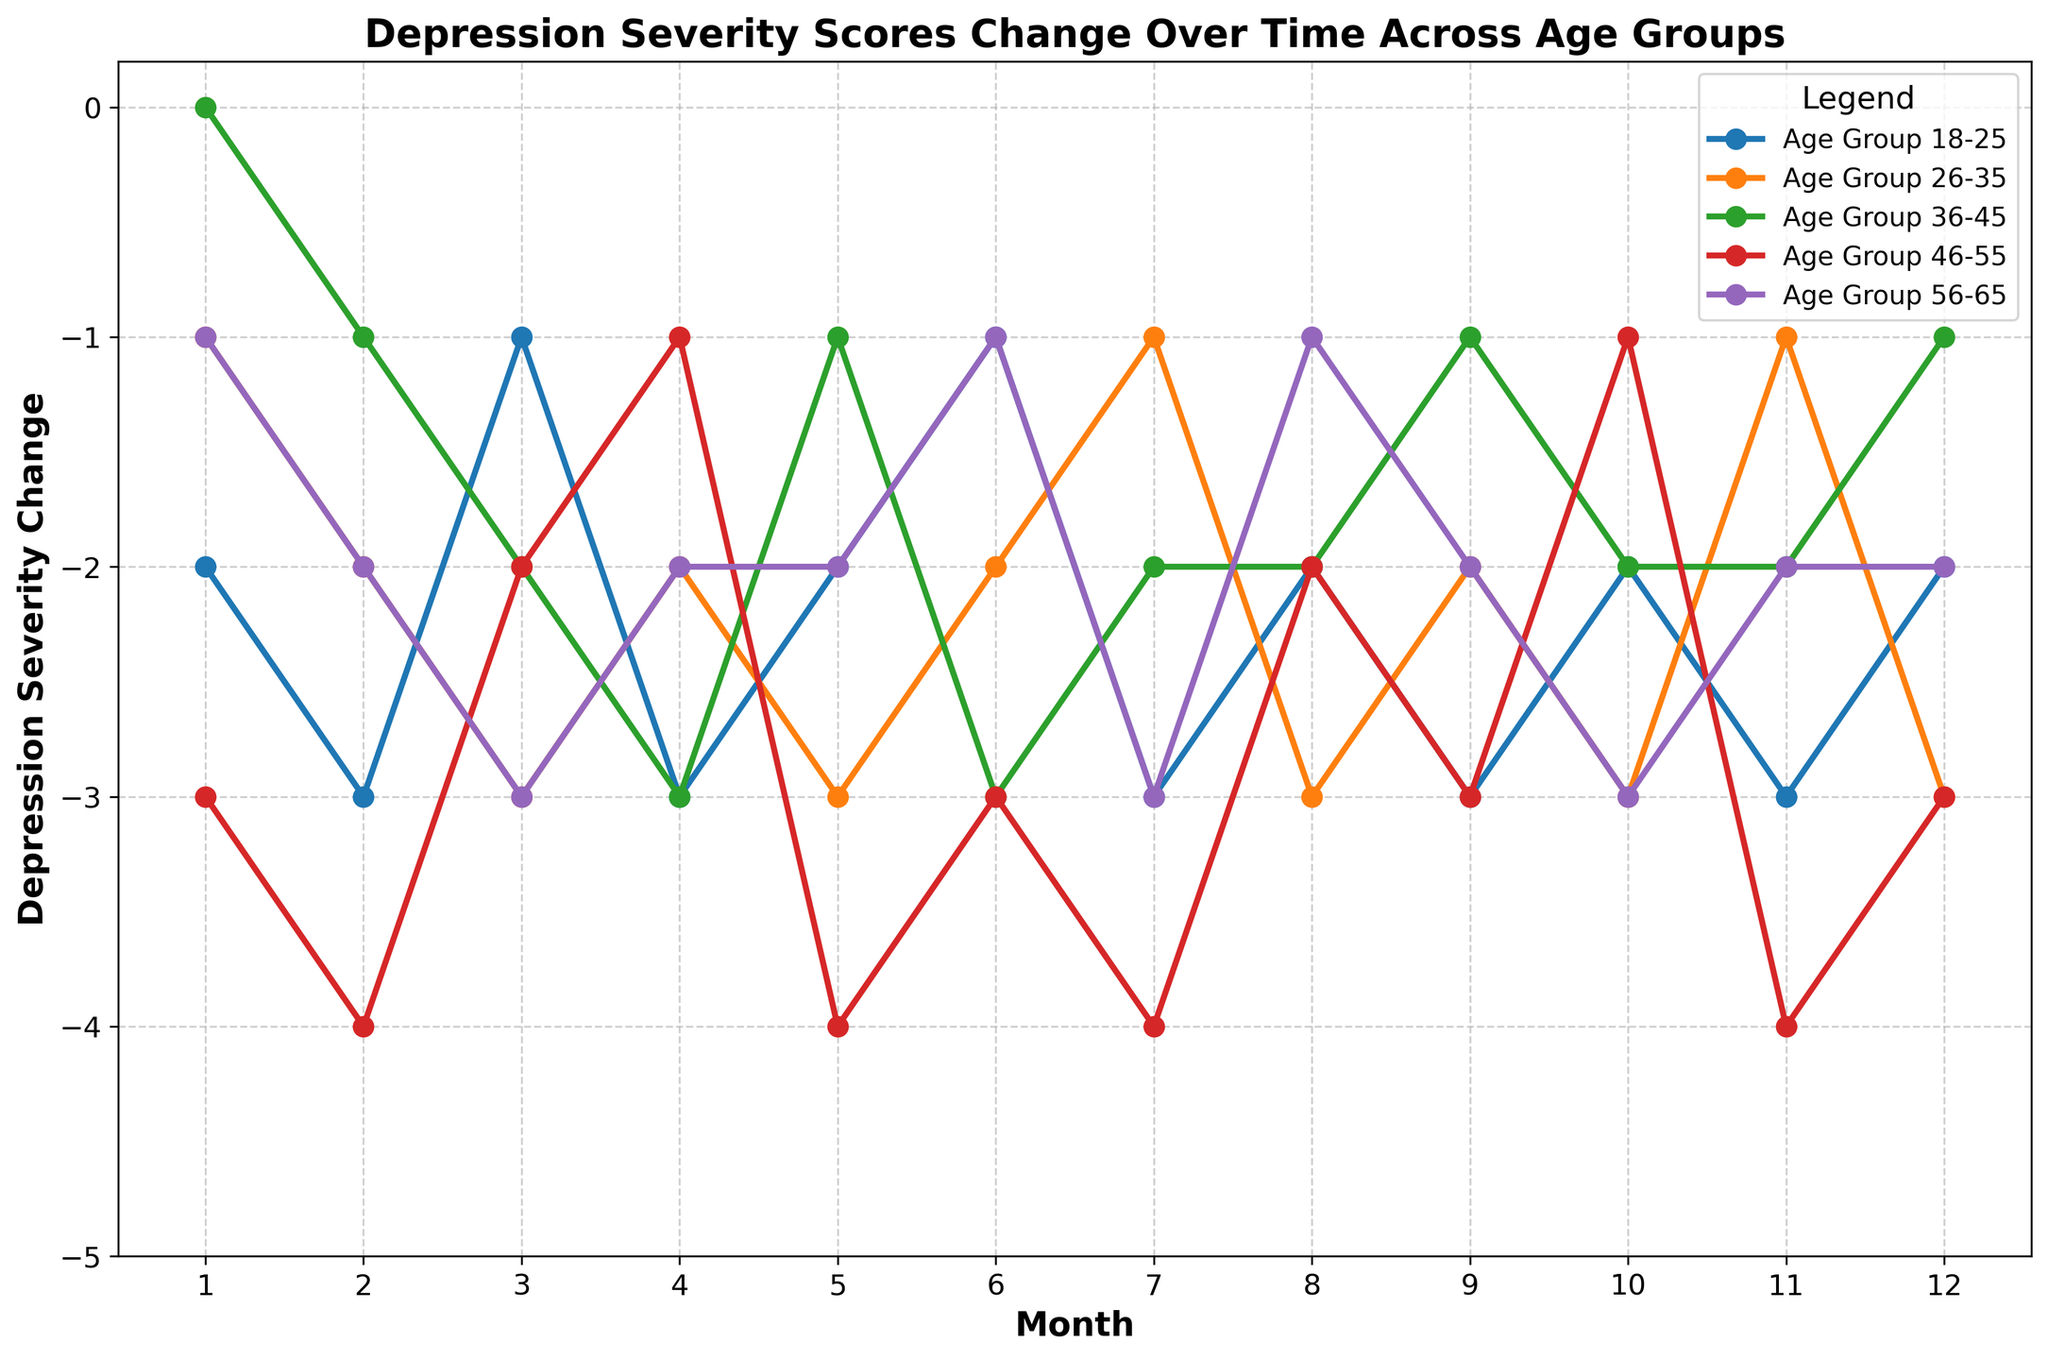Which age group experienced the least change in depression severity by the end of the year? At Month 12, we check the values for each age group. Age Group 36-45 has a value of -1 while other groups have values of -2 or -3.
Answer: 36-45 Which age group showed the most significant drop in depression severity in Month 2? In Month 2, we compare values across all age groups. Age Group 46-55 had the highest drop at -4.
Answer: 46-55 What is the average change in depression severity for the 18-25 age group over the entire period? Summing all monthly changes for the 18-25 age group: -2 - 3 - 1 - 3 - 2 - 1 - 3 - 2 - 3 - 2 - 3 - 2 = -27. Since there are 12 months, the average would be -27/12 = -2.25.
Answer: -2.25 Which age group showed the most volatile change in depression severity over the 12 months? Volatility can be observed by looking at how much the values fluctuate. Checking the values, Age Group 18-25 had changes between -1 to -3 consistently while Age Group 46-55 fluctuated between -1 to -4, indicating higher volatility for Age Group 46-55.
Answer: 46-55 How does the change in depression severity for Age Group 26-35 in Month 6 compare to Month 11? In Month 6, Ages 26-35 had -2, and in Month 11, they had -1. Comparing these shows lesser severity in Month 11 by 1 unit.
Answer: Month 11 has a lesser severity by 1 unit On average, which age group's depression severity was reduced the most over the 12 months? Calculate the average change for each group: 
- 18-25: (-27/12), 
- 26-35: (-24/12) = -2,
- 36-45: (-21/12) = -1.75,
- 46-55: (-32/12) ≈ -2.67,
- 56-65: (-22/12) ≈ -1.83.
46-55 has the highest average reduction.
Answer: 46-55 Identify the month where Age Group 36-45 experienced the highest severity drop and specify the value Observing the values for 36-45 across 12 months, the lowest value (-3) occurs in Months 4, 6, and 8.
Answer: Month 4, 6, and 8 with a value of -3 What trend is evident for the 56-65 age group over the final three months? The values for Age Group 56-65 in Months 10, 11, and 12 are -3, -2, and -2 respectively. The trend shows a slight increase in severity reduction at Month 12.
Answer: Slight increase in severity reduction Which month had universally the lowest depression severity across all age groups? By comparing values for each month across all age groups, Month 2 had the lowest values overall with -3, -2, -1, -4, and -2 respectively.
Answer: Month 2 